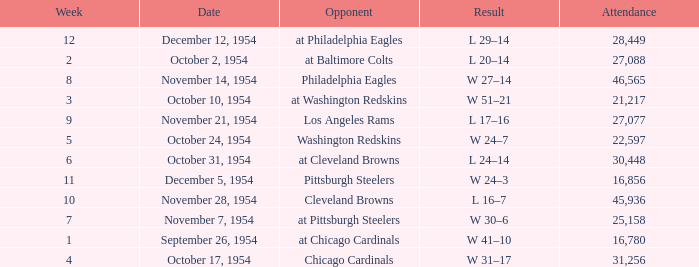How many weeks have october 31, 1954 as the date? 1.0. 